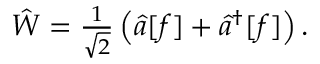Convert formula to latex. <formula><loc_0><loc_0><loc_500><loc_500>\begin{array} { r } { \hat { W } = \frac { 1 } { \sqrt { 2 } } \left ( \hat { a } [ f ] + \hat { a } ^ { \dagger } [ f ] \right ) . } \end{array}</formula> 